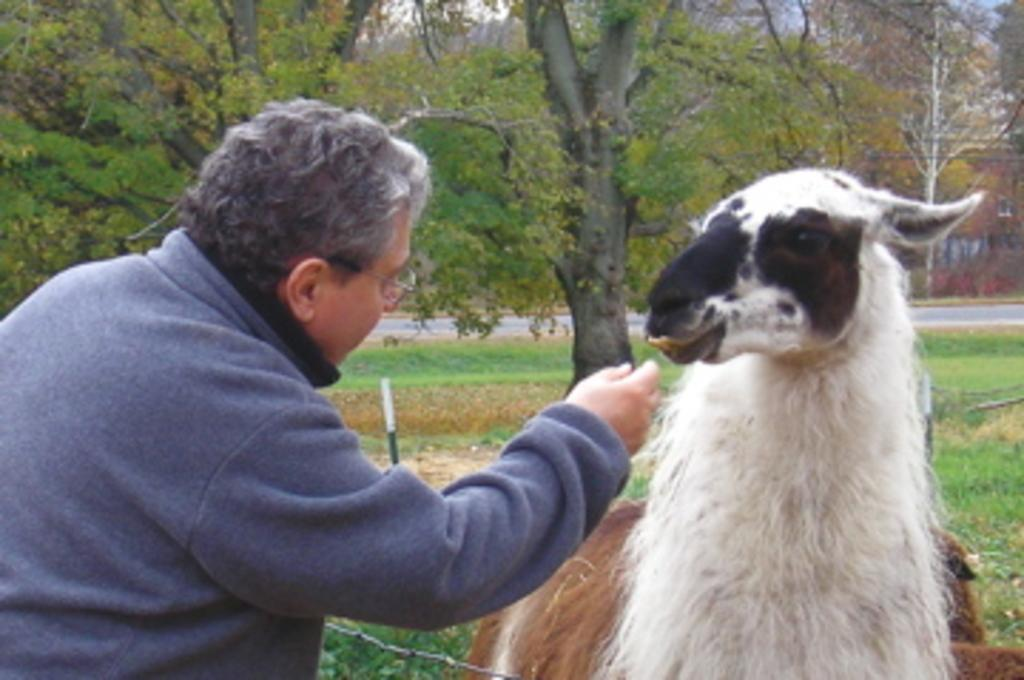Who is in the image? There is a man in the image. What is the man doing in the image? The man is feeding a sheep. What can be seen in the background of the image? There are trees and buildings visible in the background of the image. What type of surface is the man and sheep standing on? There is grass on the surface in the image. What type of grain is being used to make the jelly in the image? There is no grain or jelly present in the image; it features a man feeding a sheep on a grassy surface with trees and buildings in the background. 